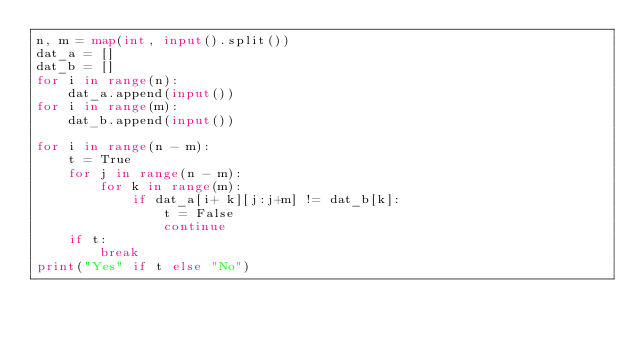<code> <loc_0><loc_0><loc_500><loc_500><_Python_>n, m = map(int, input().split())
dat_a = []
dat_b = []
for i in range(n):
    dat_a.append(input())
for i in range(m):
    dat_b.append(input())

for i in range(n - m):
    t = True
    for j in range(n - m):
        for k in range(m):
            if dat_a[i+ k][j:j+m] != dat_b[k]:
                t = False
                continue
    if t:
        break
print("Yes" if t else "No")</code> 